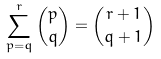Convert formula to latex. <formula><loc_0><loc_0><loc_500><loc_500>\sum _ { p = q } ^ { r } \binom { p } { q } = \binom { r + 1 } { q + 1 }</formula> 